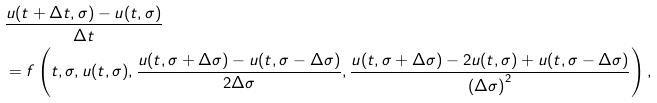Convert formula to latex. <formula><loc_0><loc_0><loc_500><loc_500>& \frac { u ( t + \Delta t , \sigma ) - u ( t , \sigma ) } { \Delta t } \\ & = f \left ( t , \sigma , u ( t , \sigma ) , \frac { u ( t , \sigma + \Delta \sigma ) - u ( t , \sigma - \Delta \sigma ) } { 2 \Delta \sigma } , \frac { u ( t , \sigma + \Delta \sigma ) - 2 u ( t , \sigma ) + u ( t , \sigma - \Delta \sigma ) } { { ( \Delta \sigma ) } ^ { 2 } } \right ) ,</formula> 